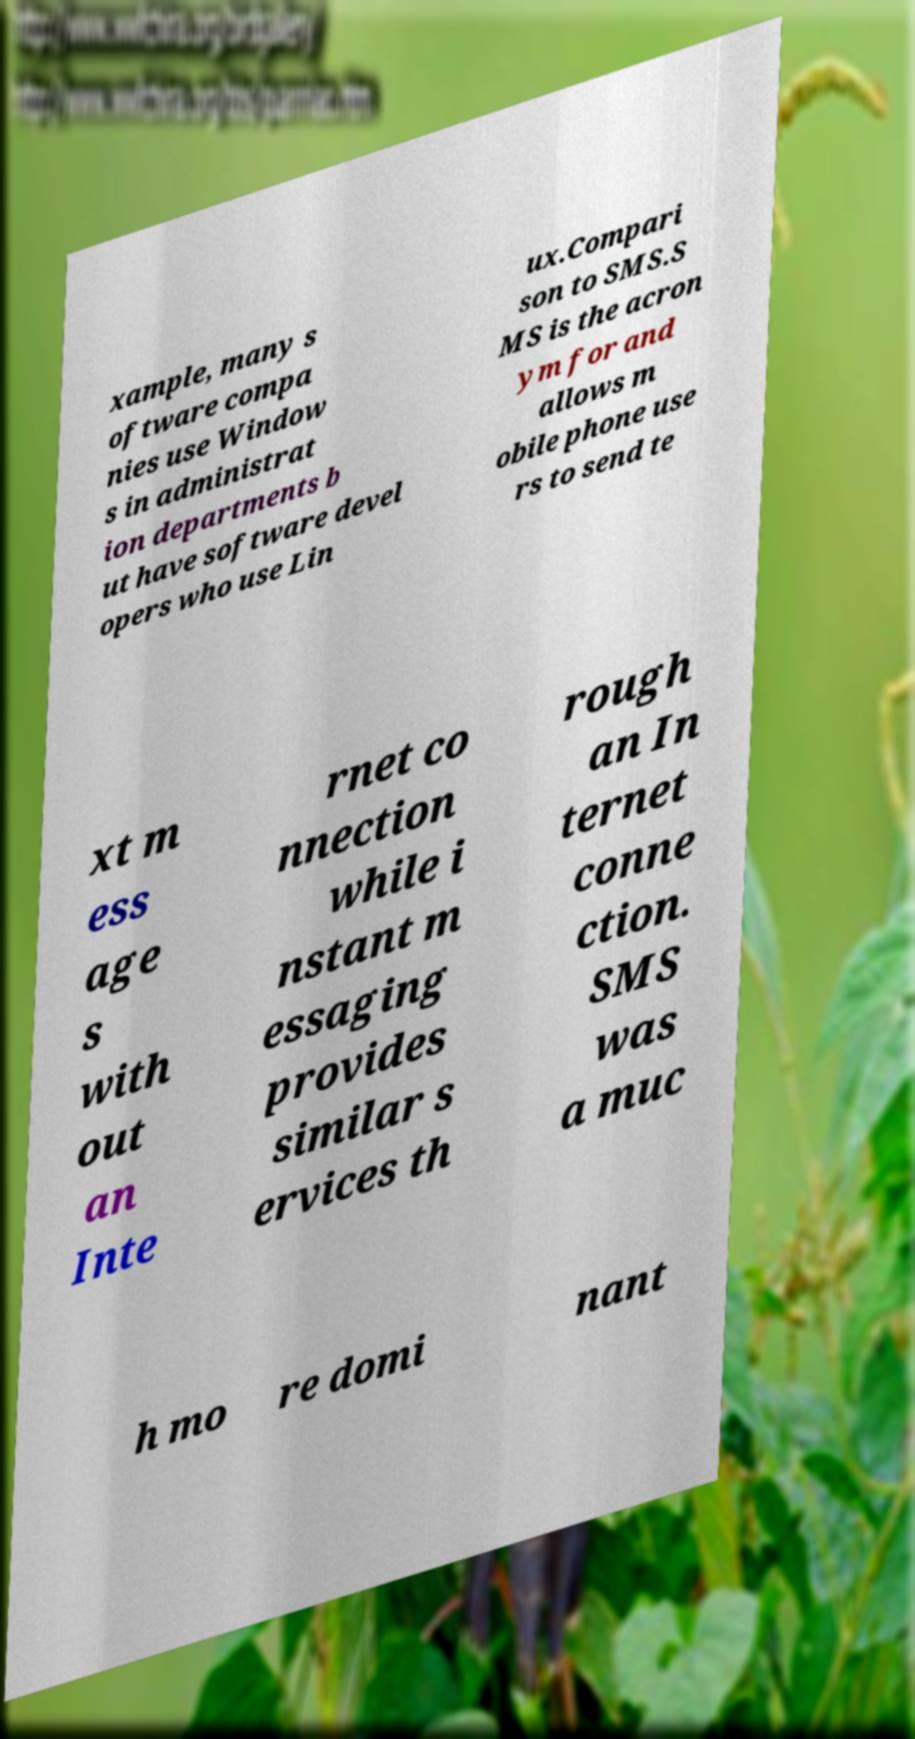There's text embedded in this image that I need extracted. Can you transcribe it verbatim? xample, many s oftware compa nies use Window s in administrat ion departments b ut have software devel opers who use Lin ux.Compari son to SMS.S MS is the acron ym for and allows m obile phone use rs to send te xt m ess age s with out an Inte rnet co nnection while i nstant m essaging provides similar s ervices th rough an In ternet conne ction. SMS was a muc h mo re domi nant 